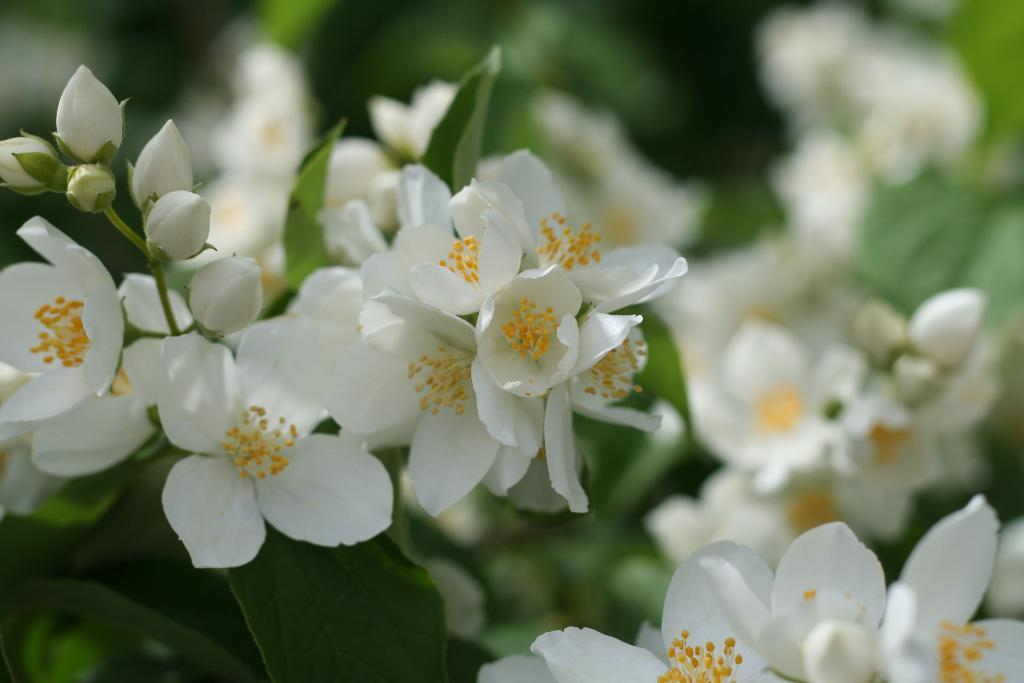What type of flowers are in the middle of the image? There are small white flowers in the middle of the image. Are there any flowers that are not fully bloomed in the image? Yes, there are buds among the flowers. What color are the leaves in the background of the image? The leaves in the background of the image are green. How does the snake twist around the flowers in the image? There is no snake present in the image; it only features small white flowers and green leaves. 